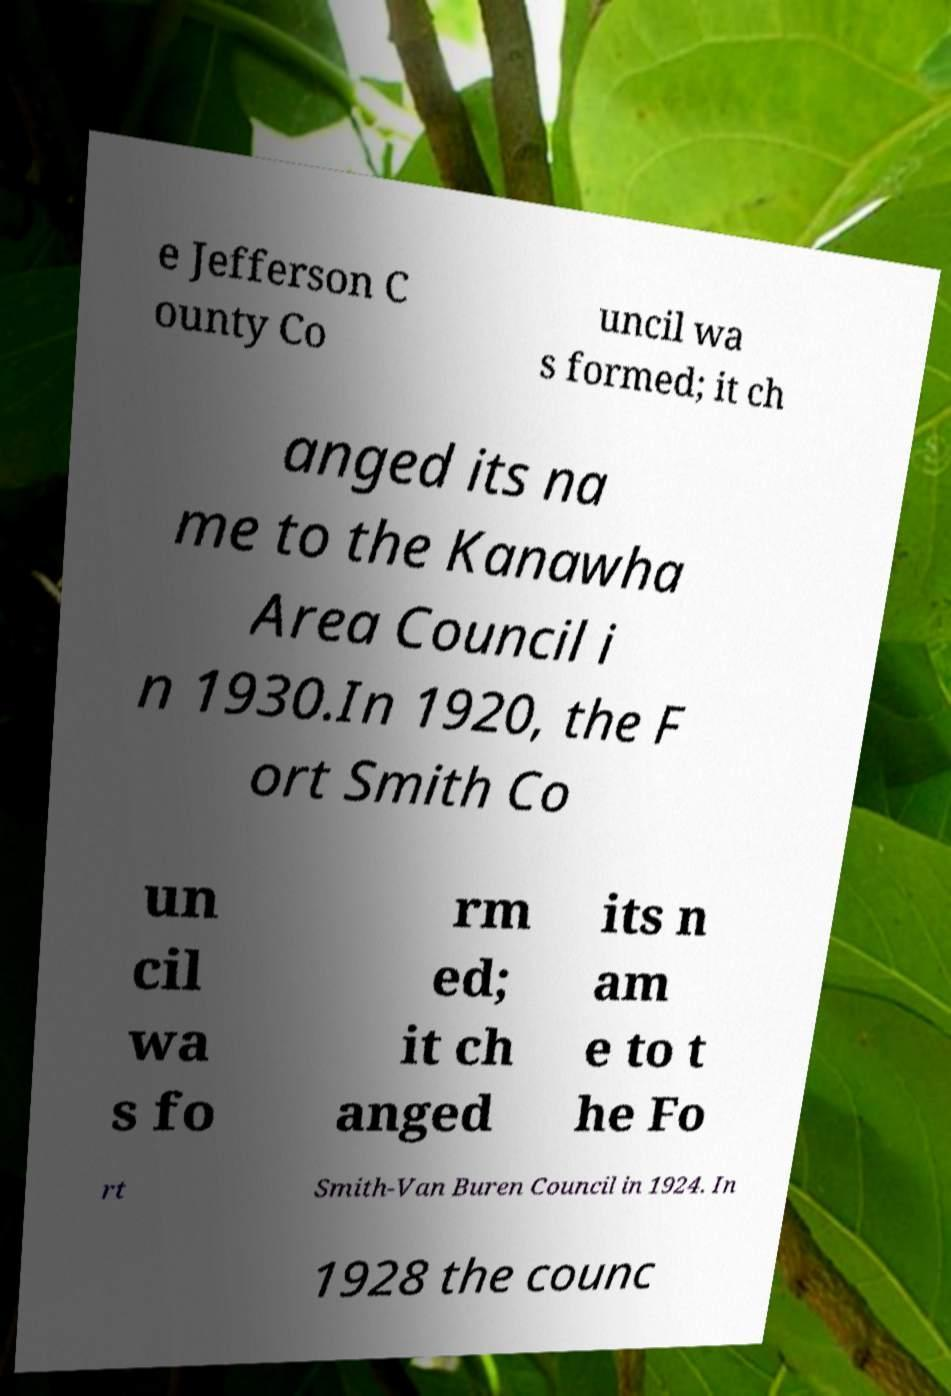Please identify and transcribe the text found in this image. e Jefferson C ounty Co uncil wa s formed; it ch anged its na me to the Kanawha Area Council i n 1930.In 1920, the F ort Smith Co un cil wa s fo rm ed; it ch anged its n am e to t he Fo rt Smith-Van Buren Council in 1924. In 1928 the counc 